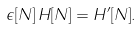<formula> <loc_0><loc_0><loc_500><loc_500>\epsilon [ N ] \, H [ N ] = H ^ { \prime } [ N ] .</formula> 